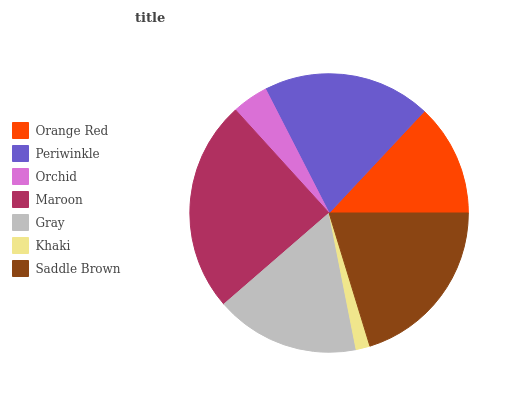Is Khaki the minimum?
Answer yes or no. Yes. Is Maroon the maximum?
Answer yes or no. Yes. Is Periwinkle the minimum?
Answer yes or no. No. Is Periwinkle the maximum?
Answer yes or no. No. Is Periwinkle greater than Orange Red?
Answer yes or no. Yes. Is Orange Red less than Periwinkle?
Answer yes or no. Yes. Is Orange Red greater than Periwinkle?
Answer yes or no. No. Is Periwinkle less than Orange Red?
Answer yes or no. No. Is Gray the high median?
Answer yes or no. Yes. Is Gray the low median?
Answer yes or no. Yes. Is Khaki the high median?
Answer yes or no. No. Is Maroon the low median?
Answer yes or no. No. 